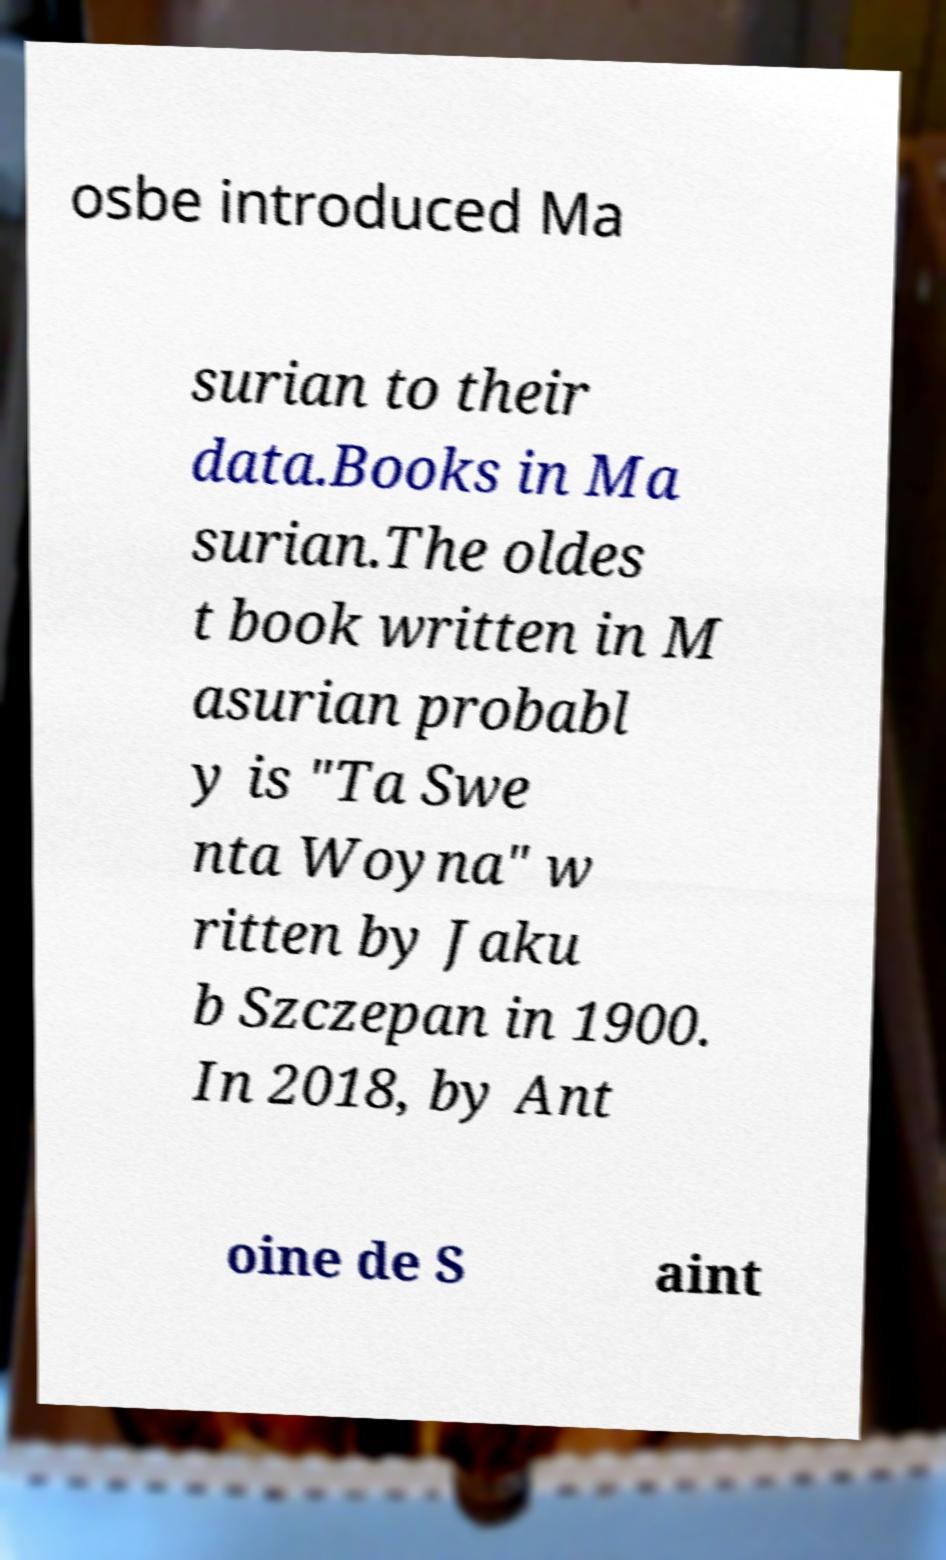Can you accurately transcribe the text from the provided image for me? osbe introduced Ma surian to their data.Books in Ma surian.The oldes t book written in M asurian probabl y is "Ta Swe nta Woyna" w ritten by Jaku b Szczepan in 1900. In 2018, by Ant oine de S aint 